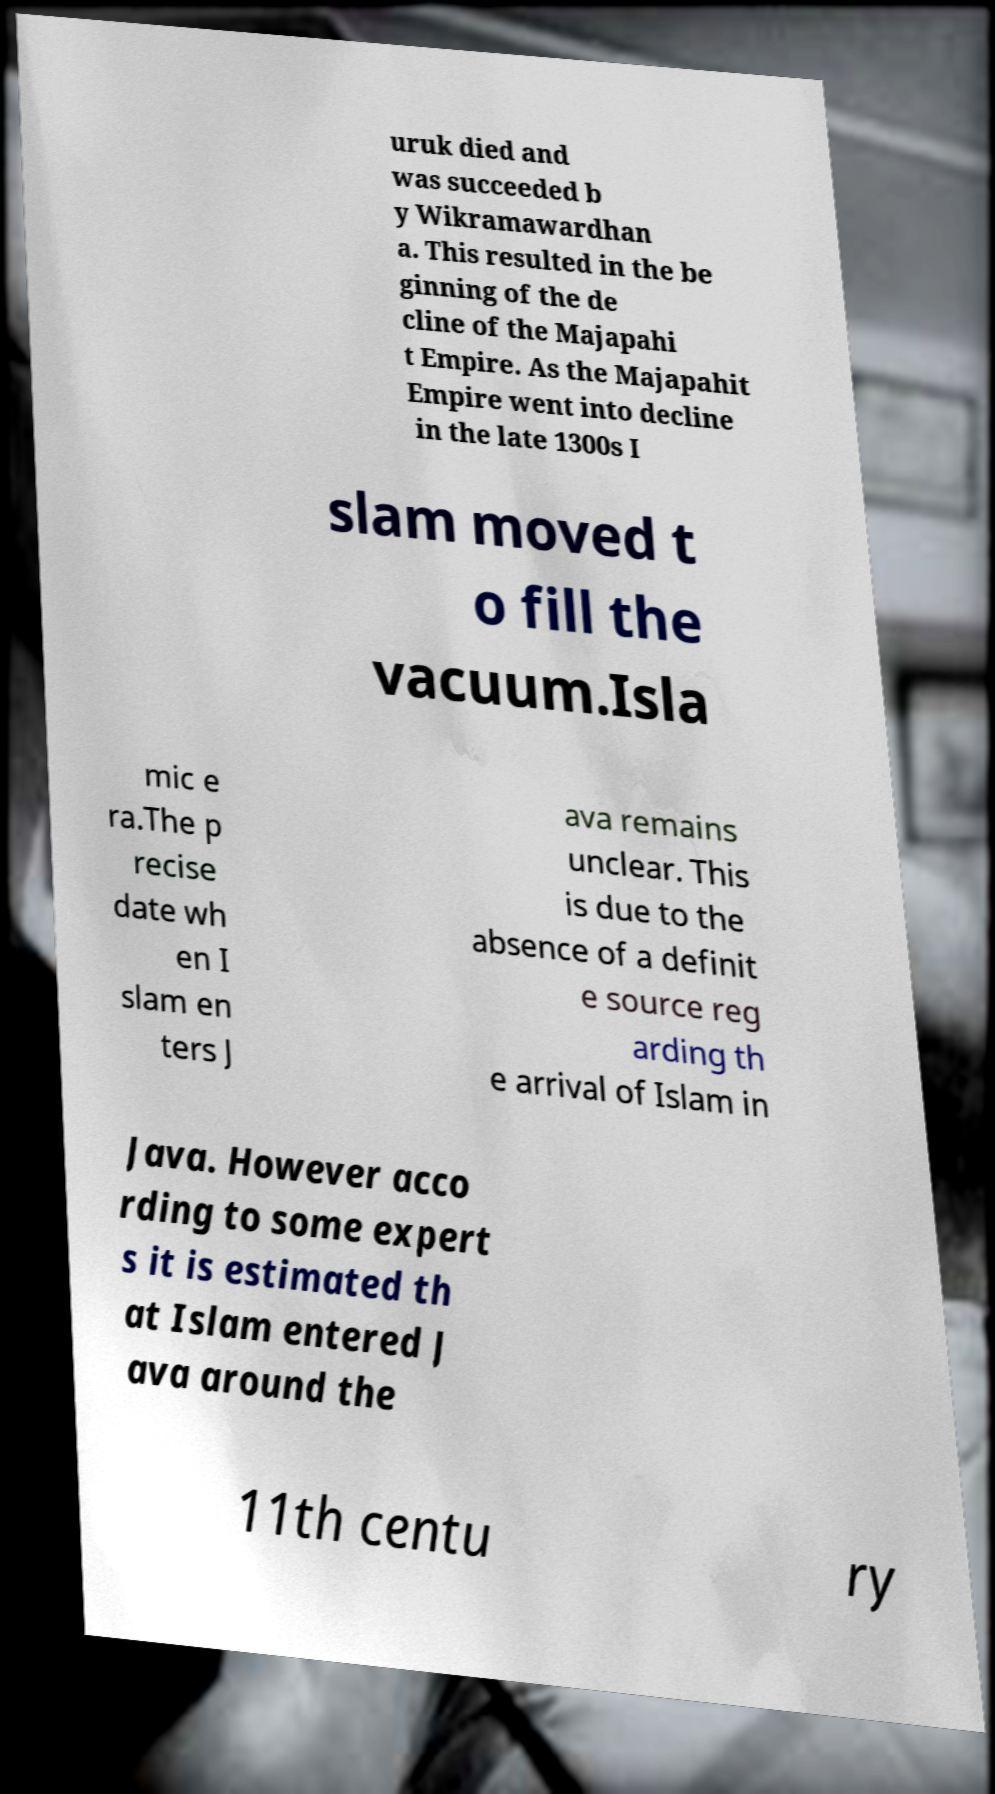Can you accurately transcribe the text from the provided image for me? uruk died and was succeeded b y Wikramawardhan a. This resulted in the be ginning of the de cline of the Majapahi t Empire. As the Majapahit Empire went into decline in the late 1300s I slam moved t o fill the vacuum.Isla mic e ra.The p recise date wh en I slam en ters J ava remains unclear. This is due to the absence of a definit e source reg arding th e arrival of Islam in Java. However acco rding to some expert s it is estimated th at Islam entered J ava around the 11th centu ry 